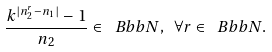<formula> <loc_0><loc_0><loc_500><loc_500>\frac { k ^ { | n _ { 2 } ^ { r } - n _ { 1 } | } - 1 } { n _ { 2 } } \in { \ B b b N } , \text { } \forall r \in { \ B b b N } .</formula> 